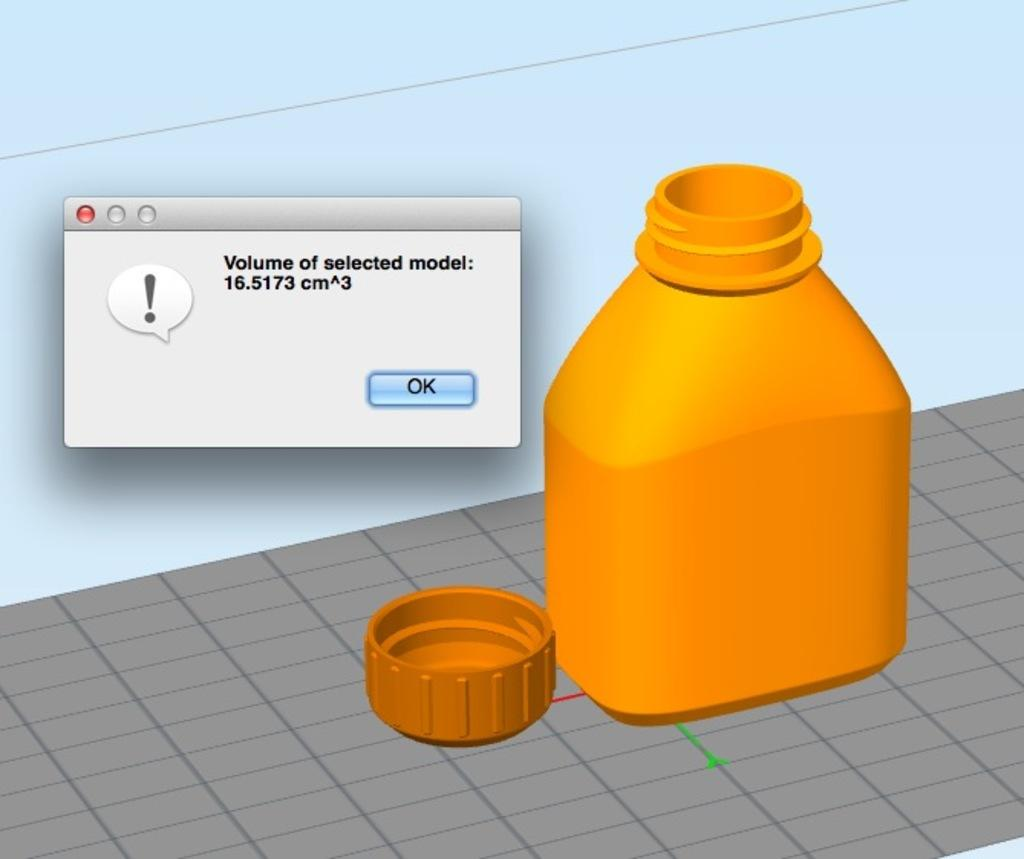<image>
Render a clear and concise summary of the photo. animation of orange bottle on a grey grid with a message stating volume of selected model: 16.5173 cm 3 